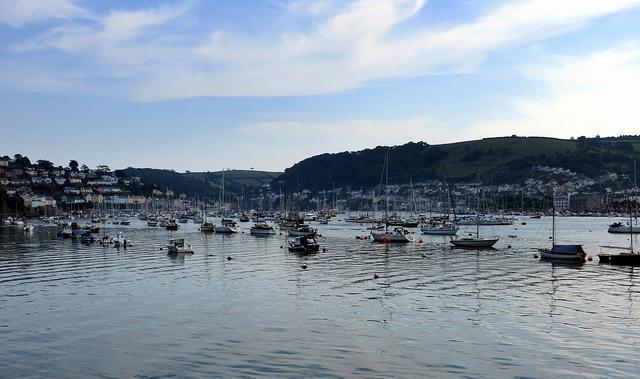How many of the people in the picture are riding bicycles?
Give a very brief answer. 0. 